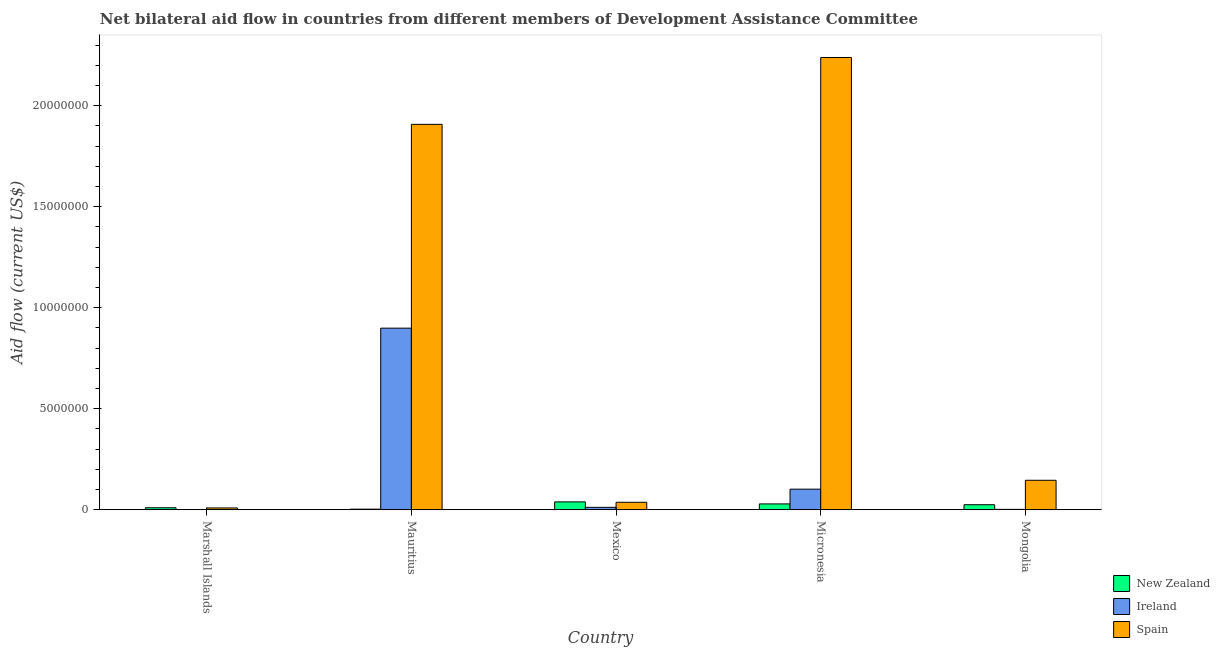How many different coloured bars are there?
Ensure brevity in your answer.  3. How many groups of bars are there?
Offer a very short reply. 5. How many bars are there on the 2nd tick from the right?
Keep it short and to the point. 3. What is the label of the 4th group of bars from the left?
Your answer should be compact. Micronesia. What is the amount of aid provided by ireland in Marshall Islands?
Keep it short and to the point. 10000. Across all countries, what is the maximum amount of aid provided by spain?
Keep it short and to the point. 2.24e+07. Across all countries, what is the minimum amount of aid provided by new zealand?
Give a very brief answer. 3.00e+04. In which country was the amount of aid provided by spain maximum?
Provide a succinct answer. Micronesia. In which country was the amount of aid provided by new zealand minimum?
Your answer should be very brief. Mauritius. What is the total amount of aid provided by ireland in the graph?
Ensure brevity in your answer.  1.02e+07. What is the difference between the amount of aid provided by spain in Mauritius and that in Micronesia?
Provide a short and direct response. -3.31e+06. What is the difference between the amount of aid provided by new zealand in Mauritius and the amount of aid provided by spain in Mongolia?
Ensure brevity in your answer.  -1.43e+06. What is the average amount of aid provided by ireland per country?
Ensure brevity in your answer.  2.03e+06. What is the difference between the amount of aid provided by ireland and amount of aid provided by spain in Mongolia?
Keep it short and to the point. -1.44e+06. What is the ratio of the amount of aid provided by ireland in Mauritius to that in Micronesia?
Your response must be concise. 8.81. Is the amount of aid provided by new zealand in Mauritius less than that in Mexico?
Offer a terse response. Yes. What is the difference between the highest and the second highest amount of aid provided by spain?
Keep it short and to the point. 3.31e+06. What is the difference between the highest and the lowest amount of aid provided by spain?
Your answer should be compact. 2.23e+07. Is the sum of the amount of aid provided by ireland in Micronesia and Mongolia greater than the maximum amount of aid provided by spain across all countries?
Your answer should be very brief. No. What does the 2nd bar from the left in Marshall Islands represents?
Your response must be concise. Ireland. What does the 3rd bar from the right in Micronesia represents?
Give a very brief answer. New Zealand. Is it the case that in every country, the sum of the amount of aid provided by new zealand and amount of aid provided by ireland is greater than the amount of aid provided by spain?
Offer a very short reply. No. How many legend labels are there?
Offer a very short reply. 3. How are the legend labels stacked?
Keep it short and to the point. Vertical. What is the title of the graph?
Your response must be concise. Net bilateral aid flow in countries from different members of Development Assistance Committee. What is the label or title of the X-axis?
Keep it short and to the point. Country. What is the label or title of the Y-axis?
Your answer should be compact. Aid flow (current US$). What is the Aid flow (current US$) in Ireland in Marshall Islands?
Your answer should be compact. 10000. What is the Aid flow (current US$) in Spain in Marshall Islands?
Ensure brevity in your answer.  9.00e+04. What is the Aid flow (current US$) of Ireland in Mauritius?
Provide a succinct answer. 8.99e+06. What is the Aid flow (current US$) of Spain in Mauritius?
Ensure brevity in your answer.  1.91e+07. What is the Aid flow (current US$) in Spain in Mexico?
Offer a terse response. 3.70e+05. What is the Aid flow (current US$) in New Zealand in Micronesia?
Your answer should be very brief. 2.90e+05. What is the Aid flow (current US$) of Ireland in Micronesia?
Offer a very short reply. 1.02e+06. What is the Aid flow (current US$) in Spain in Micronesia?
Make the answer very short. 2.24e+07. What is the Aid flow (current US$) in New Zealand in Mongolia?
Offer a very short reply. 2.50e+05. What is the Aid flow (current US$) of Spain in Mongolia?
Your answer should be very brief. 1.46e+06. Across all countries, what is the maximum Aid flow (current US$) of New Zealand?
Your response must be concise. 3.90e+05. Across all countries, what is the maximum Aid flow (current US$) in Ireland?
Offer a terse response. 8.99e+06. Across all countries, what is the maximum Aid flow (current US$) of Spain?
Make the answer very short. 2.24e+07. Across all countries, what is the minimum Aid flow (current US$) of New Zealand?
Give a very brief answer. 3.00e+04. Across all countries, what is the minimum Aid flow (current US$) in Ireland?
Keep it short and to the point. 10000. Across all countries, what is the minimum Aid flow (current US$) of Spain?
Your response must be concise. 9.00e+04. What is the total Aid flow (current US$) in New Zealand in the graph?
Your answer should be compact. 1.06e+06. What is the total Aid flow (current US$) in Ireland in the graph?
Your answer should be very brief. 1.02e+07. What is the total Aid flow (current US$) of Spain in the graph?
Your response must be concise. 4.34e+07. What is the difference between the Aid flow (current US$) of Ireland in Marshall Islands and that in Mauritius?
Give a very brief answer. -8.98e+06. What is the difference between the Aid flow (current US$) of Spain in Marshall Islands and that in Mauritius?
Offer a very short reply. -1.90e+07. What is the difference between the Aid flow (current US$) in Ireland in Marshall Islands and that in Mexico?
Offer a terse response. -1.10e+05. What is the difference between the Aid flow (current US$) of Spain in Marshall Islands and that in Mexico?
Provide a succinct answer. -2.80e+05. What is the difference between the Aid flow (current US$) of Ireland in Marshall Islands and that in Micronesia?
Keep it short and to the point. -1.01e+06. What is the difference between the Aid flow (current US$) in Spain in Marshall Islands and that in Micronesia?
Give a very brief answer. -2.23e+07. What is the difference between the Aid flow (current US$) in New Zealand in Marshall Islands and that in Mongolia?
Provide a succinct answer. -1.50e+05. What is the difference between the Aid flow (current US$) of Spain in Marshall Islands and that in Mongolia?
Provide a succinct answer. -1.37e+06. What is the difference between the Aid flow (current US$) in New Zealand in Mauritius and that in Mexico?
Give a very brief answer. -3.60e+05. What is the difference between the Aid flow (current US$) in Ireland in Mauritius and that in Mexico?
Give a very brief answer. 8.87e+06. What is the difference between the Aid flow (current US$) of Spain in Mauritius and that in Mexico?
Offer a terse response. 1.87e+07. What is the difference between the Aid flow (current US$) of New Zealand in Mauritius and that in Micronesia?
Provide a short and direct response. -2.60e+05. What is the difference between the Aid flow (current US$) in Ireland in Mauritius and that in Micronesia?
Provide a succinct answer. 7.97e+06. What is the difference between the Aid flow (current US$) of Spain in Mauritius and that in Micronesia?
Keep it short and to the point. -3.31e+06. What is the difference between the Aid flow (current US$) in Ireland in Mauritius and that in Mongolia?
Offer a very short reply. 8.97e+06. What is the difference between the Aid flow (current US$) in Spain in Mauritius and that in Mongolia?
Offer a very short reply. 1.76e+07. What is the difference between the Aid flow (current US$) in New Zealand in Mexico and that in Micronesia?
Your answer should be very brief. 1.00e+05. What is the difference between the Aid flow (current US$) in Ireland in Mexico and that in Micronesia?
Provide a succinct answer. -9.00e+05. What is the difference between the Aid flow (current US$) of Spain in Mexico and that in Micronesia?
Your answer should be compact. -2.20e+07. What is the difference between the Aid flow (current US$) in New Zealand in Mexico and that in Mongolia?
Make the answer very short. 1.40e+05. What is the difference between the Aid flow (current US$) of Spain in Mexico and that in Mongolia?
Make the answer very short. -1.09e+06. What is the difference between the Aid flow (current US$) of Spain in Micronesia and that in Mongolia?
Your response must be concise. 2.09e+07. What is the difference between the Aid flow (current US$) in New Zealand in Marshall Islands and the Aid flow (current US$) in Ireland in Mauritius?
Offer a terse response. -8.89e+06. What is the difference between the Aid flow (current US$) in New Zealand in Marshall Islands and the Aid flow (current US$) in Spain in Mauritius?
Ensure brevity in your answer.  -1.90e+07. What is the difference between the Aid flow (current US$) in Ireland in Marshall Islands and the Aid flow (current US$) in Spain in Mauritius?
Make the answer very short. -1.91e+07. What is the difference between the Aid flow (current US$) in New Zealand in Marshall Islands and the Aid flow (current US$) in Ireland in Mexico?
Provide a short and direct response. -2.00e+04. What is the difference between the Aid flow (current US$) in New Zealand in Marshall Islands and the Aid flow (current US$) in Spain in Mexico?
Provide a short and direct response. -2.70e+05. What is the difference between the Aid flow (current US$) in Ireland in Marshall Islands and the Aid flow (current US$) in Spain in Mexico?
Make the answer very short. -3.60e+05. What is the difference between the Aid flow (current US$) in New Zealand in Marshall Islands and the Aid flow (current US$) in Ireland in Micronesia?
Offer a terse response. -9.20e+05. What is the difference between the Aid flow (current US$) of New Zealand in Marshall Islands and the Aid flow (current US$) of Spain in Micronesia?
Offer a very short reply. -2.23e+07. What is the difference between the Aid flow (current US$) in Ireland in Marshall Islands and the Aid flow (current US$) in Spain in Micronesia?
Your answer should be compact. -2.24e+07. What is the difference between the Aid flow (current US$) of New Zealand in Marshall Islands and the Aid flow (current US$) of Ireland in Mongolia?
Offer a very short reply. 8.00e+04. What is the difference between the Aid flow (current US$) of New Zealand in Marshall Islands and the Aid flow (current US$) of Spain in Mongolia?
Offer a very short reply. -1.36e+06. What is the difference between the Aid flow (current US$) in Ireland in Marshall Islands and the Aid flow (current US$) in Spain in Mongolia?
Offer a very short reply. -1.45e+06. What is the difference between the Aid flow (current US$) in New Zealand in Mauritius and the Aid flow (current US$) in Ireland in Mexico?
Your answer should be compact. -9.00e+04. What is the difference between the Aid flow (current US$) in Ireland in Mauritius and the Aid flow (current US$) in Spain in Mexico?
Ensure brevity in your answer.  8.62e+06. What is the difference between the Aid flow (current US$) of New Zealand in Mauritius and the Aid flow (current US$) of Ireland in Micronesia?
Your answer should be compact. -9.90e+05. What is the difference between the Aid flow (current US$) in New Zealand in Mauritius and the Aid flow (current US$) in Spain in Micronesia?
Keep it short and to the point. -2.24e+07. What is the difference between the Aid flow (current US$) in Ireland in Mauritius and the Aid flow (current US$) in Spain in Micronesia?
Offer a very short reply. -1.34e+07. What is the difference between the Aid flow (current US$) in New Zealand in Mauritius and the Aid flow (current US$) in Ireland in Mongolia?
Provide a succinct answer. 10000. What is the difference between the Aid flow (current US$) of New Zealand in Mauritius and the Aid flow (current US$) of Spain in Mongolia?
Ensure brevity in your answer.  -1.43e+06. What is the difference between the Aid flow (current US$) of Ireland in Mauritius and the Aid flow (current US$) of Spain in Mongolia?
Your answer should be very brief. 7.53e+06. What is the difference between the Aid flow (current US$) of New Zealand in Mexico and the Aid flow (current US$) of Ireland in Micronesia?
Your response must be concise. -6.30e+05. What is the difference between the Aid flow (current US$) of New Zealand in Mexico and the Aid flow (current US$) of Spain in Micronesia?
Your answer should be compact. -2.20e+07. What is the difference between the Aid flow (current US$) of Ireland in Mexico and the Aid flow (current US$) of Spain in Micronesia?
Give a very brief answer. -2.23e+07. What is the difference between the Aid flow (current US$) in New Zealand in Mexico and the Aid flow (current US$) in Ireland in Mongolia?
Offer a terse response. 3.70e+05. What is the difference between the Aid flow (current US$) in New Zealand in Mexico and the Aid flow (current US$) in Spain in Mongolia?
Offer a very short reply. -1.07e+06. What is the difference between the Aid flow (current US$) in Ireland in Mexico and the Aid flow (current US$) in Spain in Mongolia?
Keep it short and to the point. -1.34e+06. What is the difference between the Aid flow (current US$) in New Zealand in Micronesia and the Aid flow (current US$) in Ireland in Mongolia?
Your answer should be very brief. 2.70e+05. What is the difference between the Aid flow (current US$) of New Zealand in Micronesia and the Aid flow (current US$) of Spain in Mongolia?
Provide a short and direct response. -1.17e+06. What is the difference between the Aid flow (current US$) of Ireland in Micronesia and the Aid flow (current US$) of Spain in Mongolia?
Offer a terse response. -4.40e+05. What is the average Aid flow (current US$) of New Zealand per country?
Your answer should be very brief. 2.12e+05. What is the average Aid flow (current US$) in Ireland per country?
Give a very brief answer. 2.03e+06. What is the average Aid flow (current US$) of Spain per country?
Your answer should be very brief. 8.68e+06. What is the difference between the Aid flow (current US$) of New Zealand and Aid flow (current US$) of Ireland in Marshall Islands?
Offer a very short reply. 9.00e+04. What is the difference between the Aid flow (current US$) of New Zealand and Aid flow (current US$) of Spain in Marshall Islands?
Your answer should be compact. 10000. What is the difference between the Aid flow (current US$) of New Zealand and Aid flow (current US$) of Ireland in Mauritius?
Your answer should be very brief. -8.96e+06. What is the difference between the Aid flow (current US$) in New Zealand and Aid flow (current US$) in Spain in Mauritius?
Keep it short and to the point. -1.90e+07. What is the difference between the Aid flow (current US$) in Ireland and Aid flow (current US$) in Spain in Mauritius?
Your response must be concise. -1.01e+07. What is the difference between the Aid flow (current US$) in New Zealand and Aid flow (current US$) in Ireland in Mexico?
Your response must be concise. 2.70e+05. What is the difference between the Aid flow (current US$) in New Zealand and Aid flow (current US$) in Spain in Mexico?
Ensure brevity in your answer.  2.00e+04. What is the difference between the Aid flow (current US$) of New Zealand and Aid flow (current US$) of Ireland in Micronesia?
Offer a terse response. -7.30e+05. What is the difference between the Aid flow (current US$) in New Zealand and Aid flow (current US$) in Spain in Micronesia?
Offer a very short reply. -2.21e+07. What is the difference between the Aid flow (current US$) in Ireland and Aid flow (current US$) in Spain in Micronesia?
Make the answer very short. -2.14e+07. What is the difference between the Aid flow (current US$) in New Zealand and Aid flow (current US$) in Spain in Mongolia?
Offer a terse response. -1.21e+06. What is the difference between the Aid flow (current US$) in Ireland and Aid flow (current US$) in Spain in Mongolia?
Ensure brevity in your answer.  -1.44e+06. What is the ratio of the Aid flow (current US$) in Ireland in Marshall Islands to that in Mauritius?
Your response must be concise. 0. What is the ratio of the Aid flow (current US$) of Spain in Marshall Islands to that in Mauritius?
Make the answer very short. 0. What is the ratio of the Aid flow (current US$) of New Zealand in Marshall Islands to that in Mexico?
Your answer should be very brief. 0.26. What is the ratio of the Aid flow (current US$) in Ireland in Marshall Islands to that in Mexico?
Your answer should be compact. 0.08. What is the ratio of the Aid flow (current US$) of Spain in Marshall Islands to that in Mexico?
Your answer should be compact. 0.24. What is the ratio of the Aid flow (current US$) in New Zealand in Marshall Islands to that in Micronesia?
Ensure brevity in your answer.  0.34. What is the ratio of the Aid flow (current US$) of Ireland in Marshall Islands to that in Micronesia?
Offer a very short reply. 0.01. What is the ratio of the Aid flow (current US$) of Spain in Marshall Islands to that in Micronesia?
Ensure brevity in your answer.  0. What is the ratio of the Aid flow (current US$) in Ireland in Marshall Islands to that in Mongolia?
Provide a succinct answer. 0.5. What is the ratio of the Aid flow (current US$) in Spain in Marshall Islands to that in Mongolia?
Ensure brevity in your answer.  0.06. What is the ratio of the Aid flow (current US$) of New Zealand in Mauritius to that in Mexico?
Your answer should be very brief. 0.08. What is the ratio of the Aid flow (current US$) in Ireland in Mauritius to that in Mexico?
Your answer should be compact. 74.92. What is the ratio of the Aid flow (current US$) in Spain in Mauritius to that in Mexico?
Your answer should be compact. 51.57. What is the ratio of the Aid flow (current US$) in New Zealand in Mauritius to that in Micronesia?
Your response must be concise. 0.1. What is the ratio of the Aid flow (current US$) of Ireland in Mauritius to that in Micronesia?
Provide a short and direct response. 8.81. What is the ratio of the Aid flow (current US$) of Spain in Mauritius to that in Micronesia?
Your answer should be compact. 0.85. What is the ratio of the Aid flow (current US$) of New Zealand in Mauritius to that in Mongolia?
Offer a terse response. 0.12. What is the ratio of the Aid flow (current US$) in Ireland in Mauritius to that in Mongolia?
Provide a succinct answer. 449.5. What is the ratio of the Aid flow (current US$) of Spain in Mauritius to that in Mongolia?
Offer a terse response. 13.07. What is the ratio of the Aid flow (current US$) of New Zealand in Mexico to that in Micronesia?
Keep it short and to the point. 1.34. What is the ratio of the Aid flow (current US$) of Ireland in Mexico to that in Micronesia?
Offer a terse response. 0.12. What is the ratio of the Aid flow (current US$) of Spain in Mexico to that in Micronesia?
Keep it short and to the point. 0.02. What is the ratio of the Aid flow (current US$) of New Zealand in Mexico to that in Mongolia?
Give a very brief answer. 1.56. What is the ratio of the Aid flow (current US$) of Ireland in Mexico to that in Mongolia?
Offer a very short reply. 6. What is the ratio of the Aid flow (current US$) in Spain in Mexico to that in Mongolia?
Keep it short and to the point. 0.25. What is the ratio of the Aid flow (current US$) in New Zealand in Micronesia to that in Mongolia?
Provide a short and direct response. 1.16. What is the ratio of the Aid flow (current US$) in Spain in Micronesia to that in Mongolia?
Your answer should be very brief. 15.34. What is the difference between the highest and the second highest Aid flow (current US$) of Ireland?
Give a very brief answer. 7.97e+06. What is the difference between the highest and the second highest Aid flow (current US$) of Spain?
Your answer should be very brief. 3.31e+06. What is the difference between the highest and the lowest Aid flow (current US$) in New Zealand?
Offer a very short reply. 3.60e+05. What is the difference between the highest and the lowest Aid flow (current US$) of Ireland?
Your answer should be compact. 8.98e+06. What is the difference between the highest and the lowest Aid flow (current US$) of Spain?
Offer a very short reply. 2.23e+07. 